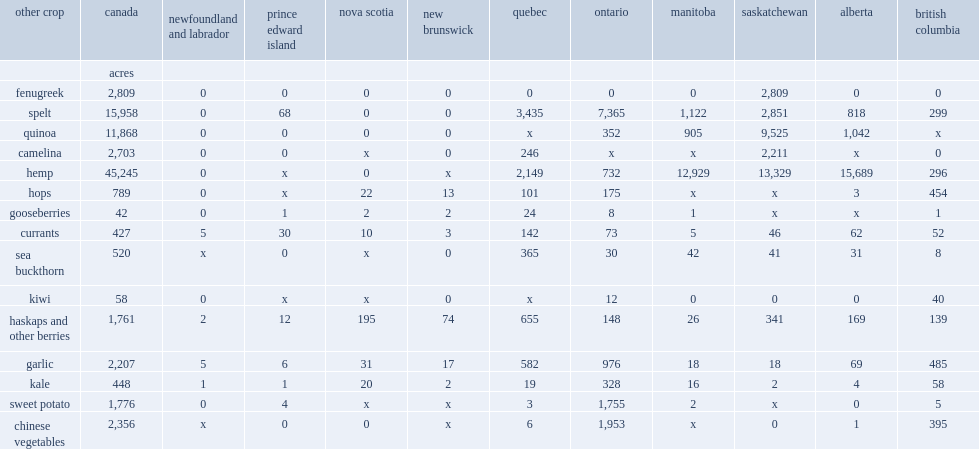How many acres of fengugreek are reported in 2016? 2809. For fenugreek area, how many percent of crop area was reported in saskatchewan,. 1. What fraction of the crop area devoted to garlic was in quebec? 0.263706. Which sector has a slighter higher propotion of crop area devoted to garlic? quebec? or british columbia. Quebec. How many percent of the crop area devoted to garlic was in british columbia? 0.219755. Which country had the largest area of garlic crop production? Ontario. What percentage of the 2207 acres of garlic in canada is reported by farms in ontario? 0.442229. What percentage of the 1776 acres of sweet potatoes reported were located in ontario? 0.988176. 